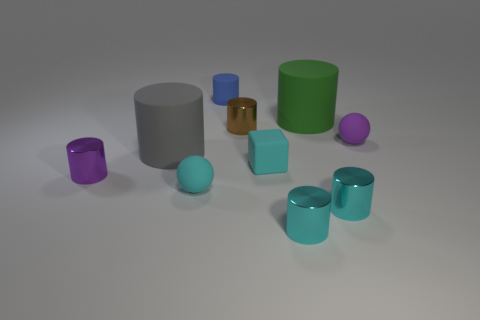Can you describe the lighting in the image? The image features soft, diffused lighting that casts gentle shadows on the right side of the objects, suggesting a light source to the left. The even lighting minimizes harsh shadows, providing a clear view of the objects' colors and shapes. 